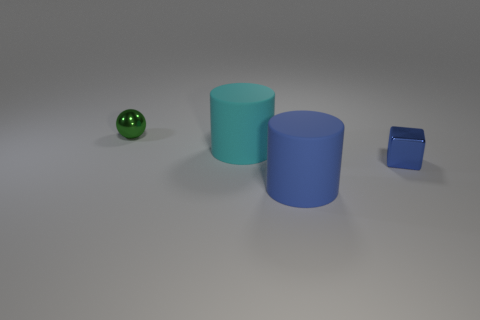Add 1 green things. How many objects exist? 5 Subtract all blocks. How many objects are left? 3 Add 2 blue metal blocks. How many blue metal blocks exist? 3 Subtract 0 green cubes. How many objects are left? 4 Subtract all gray shiny blocks. Subtract all big matte cylinders. How many objects are left? 2 Add 3 big rubber things. How many big rubber things are left? 5 